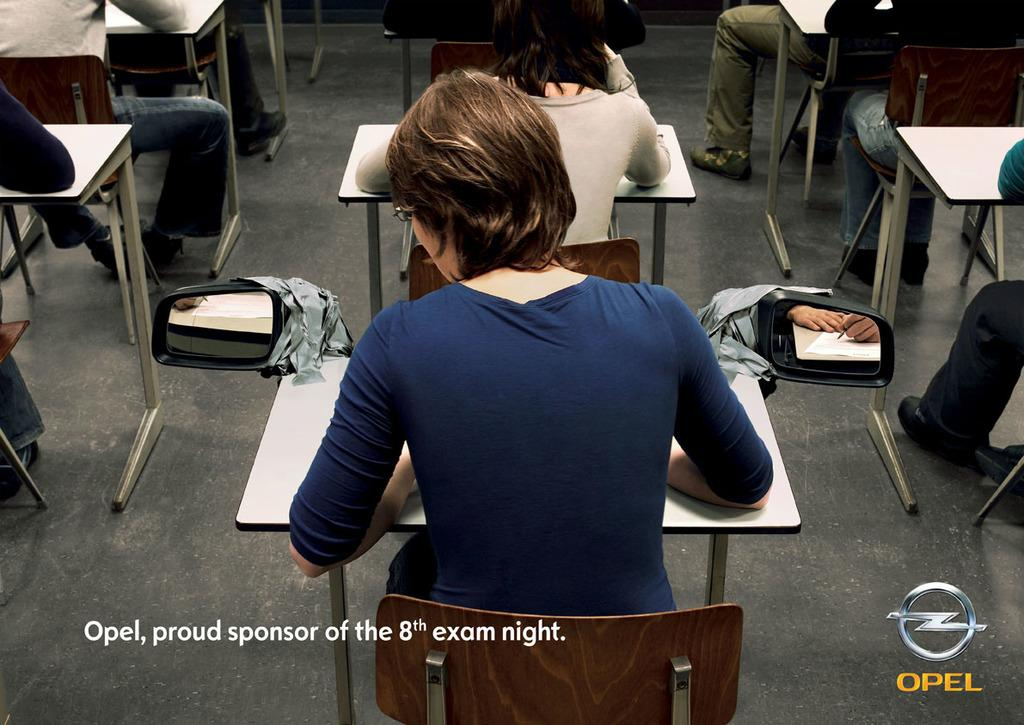Who is the main subject in the image? There is a lady in the image. What is the lady doing in the image? The lady is sitting on a chair. Where is the lady located in the image? The lady is in front of a desk. What type of setting is depicted in the image? The setting appears to be a classroom. How many centimeters long is the cloud in the image? There is no cloud present in the image. What type of coil is wrapped around the lady's chair in the image? There is no coil present in the image. 